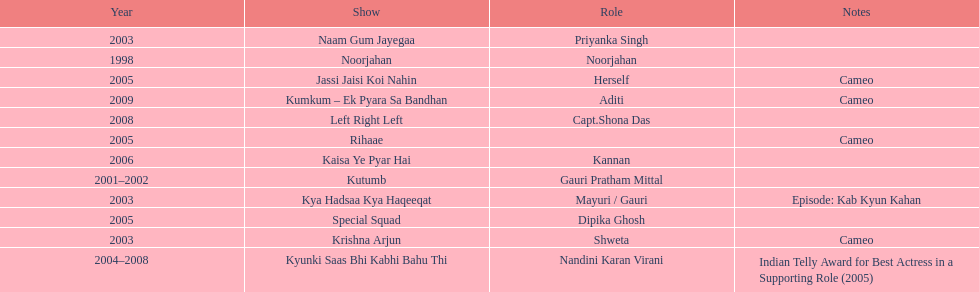Which was the only television show gauri starred in, in which she played herself? Jassi Jaisi Koi Nahin. 